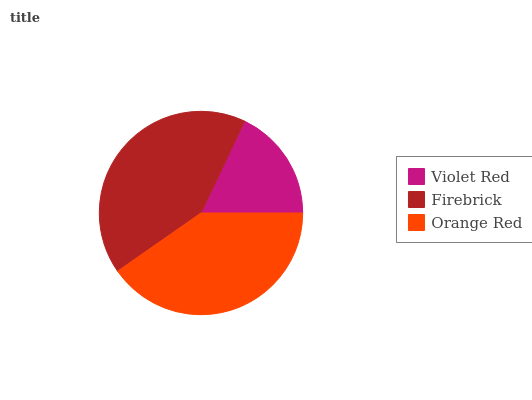Is Violet Red the minimum?
Answer yes or no. Yes. Is Firebrick the maximum?
Answer yes or no. Yes. Is Orange Red the minimum?
Answer yes or no. No. Is Orange Red the maximum?
Answer yes or no. No. Is Firebrick greater than Orange Red?
Answer yes or no. Yes. Is Orange Red less than Firebrick?
Answer yes or no. Yes. Is Orange Red greater than Firebrick?
Answer yes or no. No. Is Firebrick less than Orange Red?
Answer yes or no. No. Is Orange Red the high median?
Answer yes or no. Yes. Is Orange Red the low median?
Answer yes or no. Yes. Is Violet Red the high median?
Answer yes or no. No. Is Violet Red the low median?
Answer yes or no. No. 